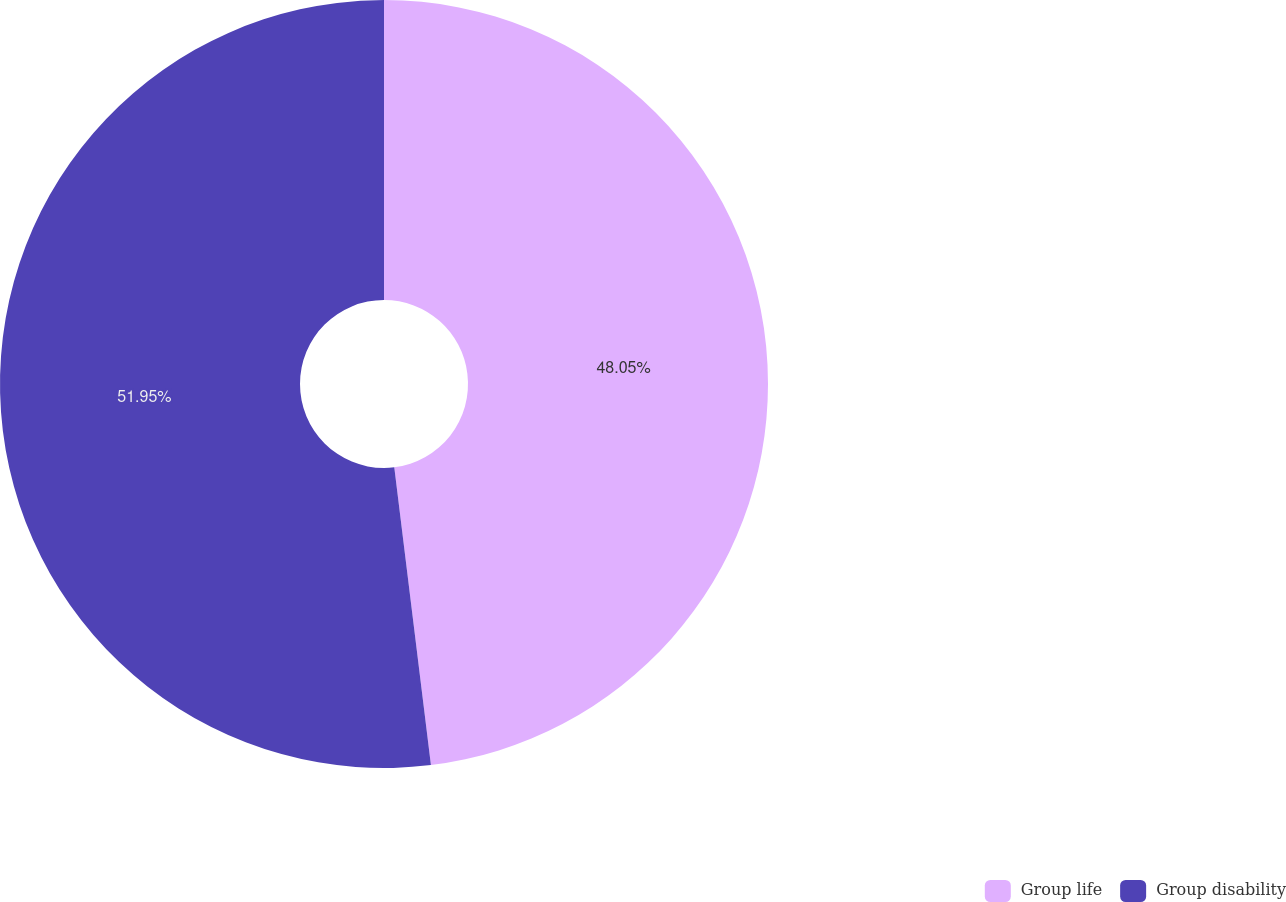Convert chart to OTSL. <chart><loc_0><loc_0><loc_500><loc_500><pie_chart><fcel>Group life<fcel>Group disability<nl><fcel>48.05%<fcel>51.95%<nl></chart> 